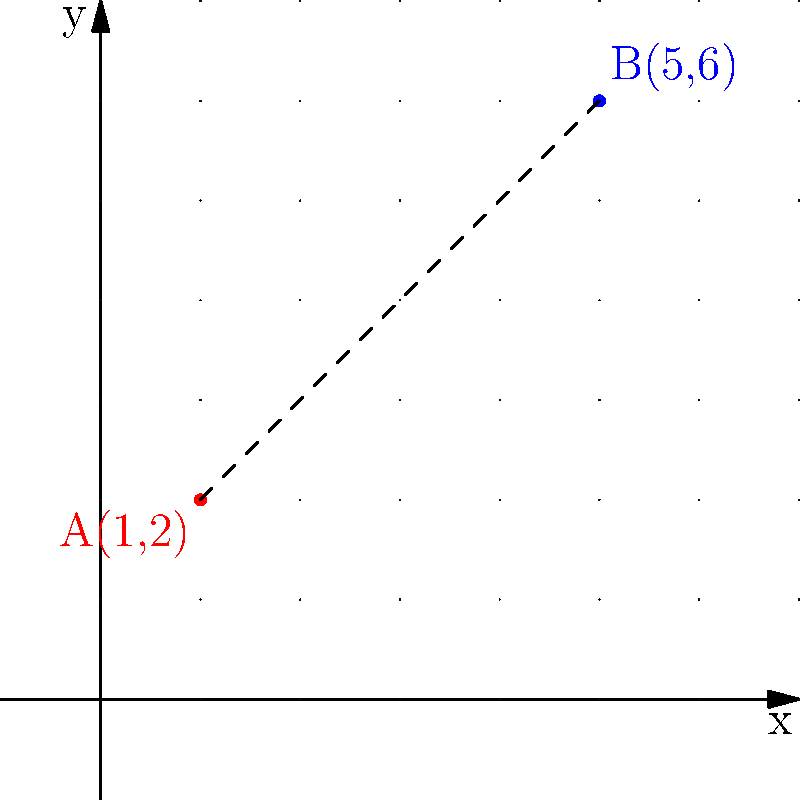Calculate the distance between points A(1,2) and B(5,6) on the coordinate plane. How would you approach this problem using Vim's text manipulation capabilities to streamline the calculation process? To solve this problem efficiently using Vim, we can follow these steps:

1. Enter the coordinates into Vim:
   ```
   A(1,2)
   B(5,6)
   ```

2. Use Vim's text manipulation to extract the x and y coordinates:
   - Use `yy` to yank the first line
   - Use `p` to paste it below
   - Use `cwx1<Esc>` to change "A" to "x1"
   - Repeat for y1, x2, and y2

3. Now we have:
   ```
   x1(1,2)
   y1(1,2)
   x2(5,6)
   y2(5,6)
   ```

4. Use search and replace to isolate the numbers:
   `:%s/[a-z0-9](//g` and `:%s/,.*//g`

5. Now we have:
   ```
   1
   2
   5
   6
   ```

6. Use Vim's math capabilities to calculate the differences:
   - `ggyyp` to duplicate the first line
   - `3jyyP` to copy the third line above it
   - Use `C<C-R>=<C-R>"5 - <C-R>"1<CR><Esc>` to calculate x2 - x1
   - Repeat for y2 - y1

7. Now we have:
   ```
   4
   4
   1
   2
   5
   6
   ```

8. Square these differences:
   - On each line: `C<C-R>=<C-R>"*<C-R>"<CR><Esc>`

9. Sum the squares:
   - `ggVG:s/\n/+/g` to join all lines with '+'
   - `A<C-R>=<C-R>"<CR><Esc>` to evaluate the sum

10. Take the square root:
    - `C<C-R>=sqrt(<C-R>")<CR><Esc>`

The final result should be approximately 5.656854249492381.

Using the distance formula: $d = \sqrt{(x_2-x_1)^2 + (y_2-y_1)^2}$

$d = \sqrt{(5-1)^2 + (6-2)^2} = \sqrt{4^2 + 4^2} = \sqrt{32} = 4\sqrt{2} \approx 5.66$
Answer: $4\sqrt{2}$ or approximately 5.66 